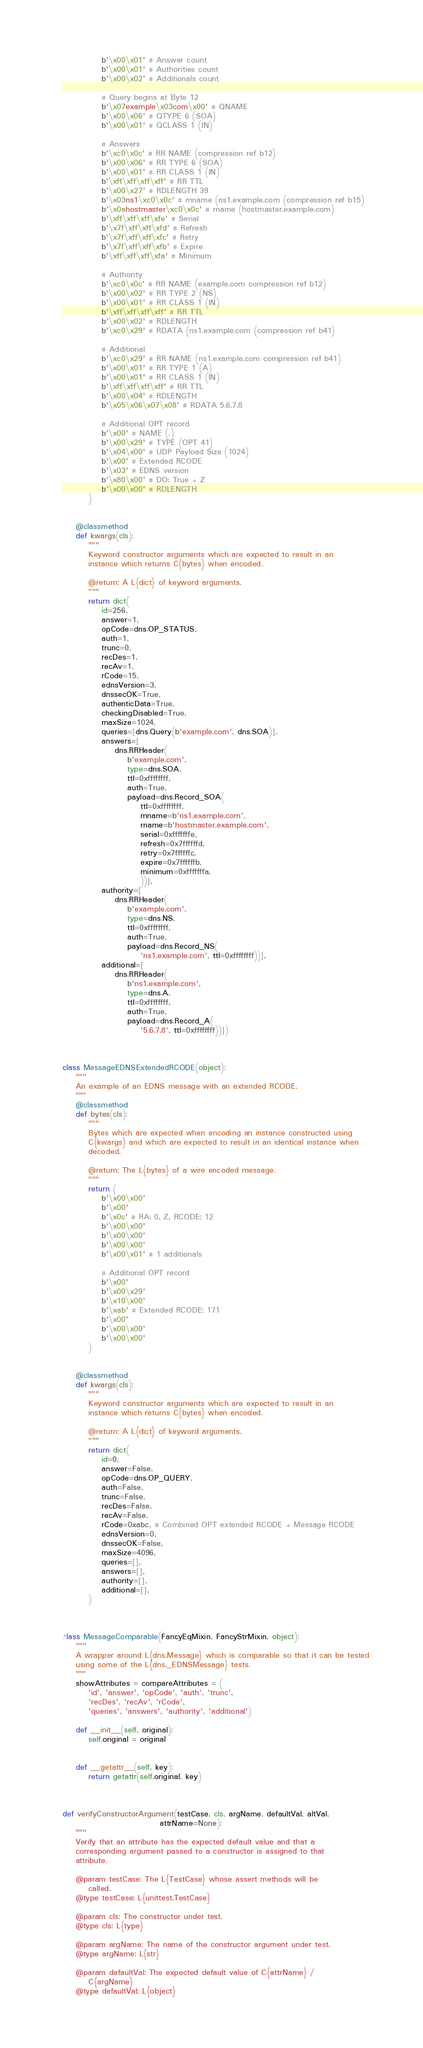<code> <loc_0><loc_0><loc_500><loc_500><_Python_>            b'\x00\x01' # Answer count
            b'\x00\x01' # Authorities count
            b'\x00\x02' # Additionals count

            # Query begins at Byte 12
            b'\x07example\x03com\x00' # QNAME
            b'\x00\x06' # QTYPE 6 (SOA)
            b'\x00\x01' # QCLASS 1 (IN)

            # Answers
            b'\xc0\x0c' # RR NAME (compression ref b12)
            b'\x00\x06' # RR TYPE 6 (SOA)
            b'\x00\x01' # RR CLASS 1 (IN)
            b'\xff\xff\xff\xff' # RR TTL
            b'\x00\x27' # RDLENGTH 39
            b'\x03ns1\xc0\x0c' # mname (ns1.example.com (compression ref b15)
            b'\x0ahostmaster\xc0\x0c' # rname (hostmaster.example.com)
            b'\xff\xff\xff\xfe' # Serial
            b'\x7f\xff\xff\xfd' # Refresh
            b'\x7f\xff\xff\xfc' # Retry
            b'\x7f\xff\xff\xfb' # Expire
            b'\xff\xff\xff\xfa' # Minimum

            # Authority
            b'\xc0\x0c' # RR NAME (example.com compression ref b12)
            b'\x00\x02' # RR TYPE 2 (NS)
            b'\x00\x01' # RR CLASS 1 (IN)
            b'\xff\xff\xff\xff' # RR TTL
            b'\x00\x02' # RDLENGTH
            b'\xc0\x29' # RDATA (ns1.example.com (compression ref b41)

            # Additional
            b'\xc0\x29' # RR NAME (ns1.example.com compression ref b41)
            b'\x00\x01' # RR TYPE 1 (A)
            b'\x00\x01' # RR CLASS 1 (IN)
            b'\xff\xff\xff\xff' # RR TTL
            b'\x00\x04' # RDLENGTH
            b'\x05\x06\x07\x08' # RDATA 5.6.7.8

            # Additional OPT record
            b'\x00' # NAME (.)
            b'\x00\x29' # TYPE (OPT 41)
            b'\x04\x00' # UDP Payload Size (1024)
            b'\x00' # Extended RCODE
            b'\x03' # EDNS version
            b'\x80\x00' # DO: True + Z
            b'\x00\x00' # RDLENGTH
        )


    @classmethod
    def kwargs(cls):
        """
        Keyword constructor arguments which are expected to result in an
        instance which returns C{bytes} when encoded.

        @return: A L{dict} of keyword arguments.
        """
        return dict(
            id=256,
            answer=1,
            opCode=dns.OP_STATUS,
            auth=1,
            trunc=0,
            recDes=1,
            recAv=1,
            rCode=15,
            ednsVersion=3,
            dnssecOK=True,
            authenticData=True,
            checkingDisabled=True,
            maxSize=1024,
            queries=[dns.Query(b'example.com', dns.SOA)],
            answers=[
                dns.RRHeader(
                    b'example.com',
                    type=dns.SOA,
                    ttl=0xffffffff,
                    auth=True,
                    payload=dns.Record_SOA(
                        ttl=0xffffffff,
                        mname=b'ns1.example.com',
                        rname=b'hostmaster.example.com',
                        serial=0xfffffffe,
                        refresh=0x7ffffffd,
                        retry=0x7ffffffc,
                        expire=0x7ffffffb,
                        minimum=0xfffffffa,
                        ))],
            authority=[
                dns.RRHeader(
                    b'example.com',
                    type=dns.NS,
                    ttl=0xffffffff,
                    auth=True,
                    payload=dns.Record_NS(
                        'ns1.example.com', ttl=0xffffffff))],
            additional=[
                dns.RRHeader(
                    b'ns1.example.com',
                    type=dns.A,
                    ttl=0xffffffff,
                    auth=True,
                    payload=dns.Record_A(
                        '5.6.7.8', ttl=0xffffffff))])



class MessageEDNSExtendedRCODE(object):
    """
    An example of an EDNS message with an extended RCODE.
    """
    @classmethod
    def bytes(cls):
        """
        Bytes which are expected when encoding an instance constructed using
        C{kwargs} and which are expected to result in an identical instance when
        decoded.

        @return: The L{bytes} of a wire encoded message.
        """
        return (
            b'\x00\x00'
            b'\x00'
            b'\x0c' # RA: 0, Z, RCODE: 12
            b'\x00\x00'
            b'\x00\x00'
            b'\x00\x00'
            b'\x00\x01' # 1 additionals

            # Additional OPT record
            b'\x00'
            b'\x00\x29'
            b'\x10\x00'
            b'\xab' # Extended RCODE: 171
            b'\x00'
            b'\x00\x00'
            b'\x00\x00'
        )


    @classmethod
    def kwargs(cls):
        """
        Keyword constructor arguments which are expected to result in an
        instance which returns C{bytes} when encoded.

        @return: A L{dict} of keyword arguments.
        """
        return dict(
            id=0,
            answer=False,
            opCode=dns.OP_QUERY,
            auth=False,
            trunc=False,
            recDes=False,
            recAv=False,
            rCode=0xabc, # Combined OPT extended RCODE + Message RCODE
            ednsVersion=0,
            dnssecOK=False,
            maxSize=4096,
            queries=[],
            answers=[],
            authority=[],
            additional=[],
        )



class MessageComparable(FancyEqMixin, FancyStrMixin, object):
    """
    A wrapper around L{dns.Message} which is comparable so that it can be tested
    using some of the L{dns._EDNSMessage} tests.
    """
    showAttributes = compareAttributes = (
        'id', 'answer', 'opCode', 'auth', 'trunc',
        'recDes', 'recAv', 'rCode',
        'queries', 'answers', 'authority', 'additional')

    def __init__(self, original):
        self.original = original


    def __getattr__(self, key):
        return getattr(self.original, key)



def verifyConstructorArgument(testCase, cls, argName, defaultVal, altVal,
                              attrName=None):
    """
    Verify that an attribute has the expected default value and that a
    corresponding argument passed to a constructor is assigned to that
    attribute.

    @param testCase: The L{TestCase} whose assert methods will be
        called.
    @type testCase: L{unittest.TestCase}

    @param cls: The constructor under test.
    @type cls: L{type}

    @param argName: The name of the constructor argument under test.
    @type argName: L{str}

    @param defaultVal: The expected default value of C{attrName} /
        C{argName}
    @type defaultVal: L{object}
</code> 